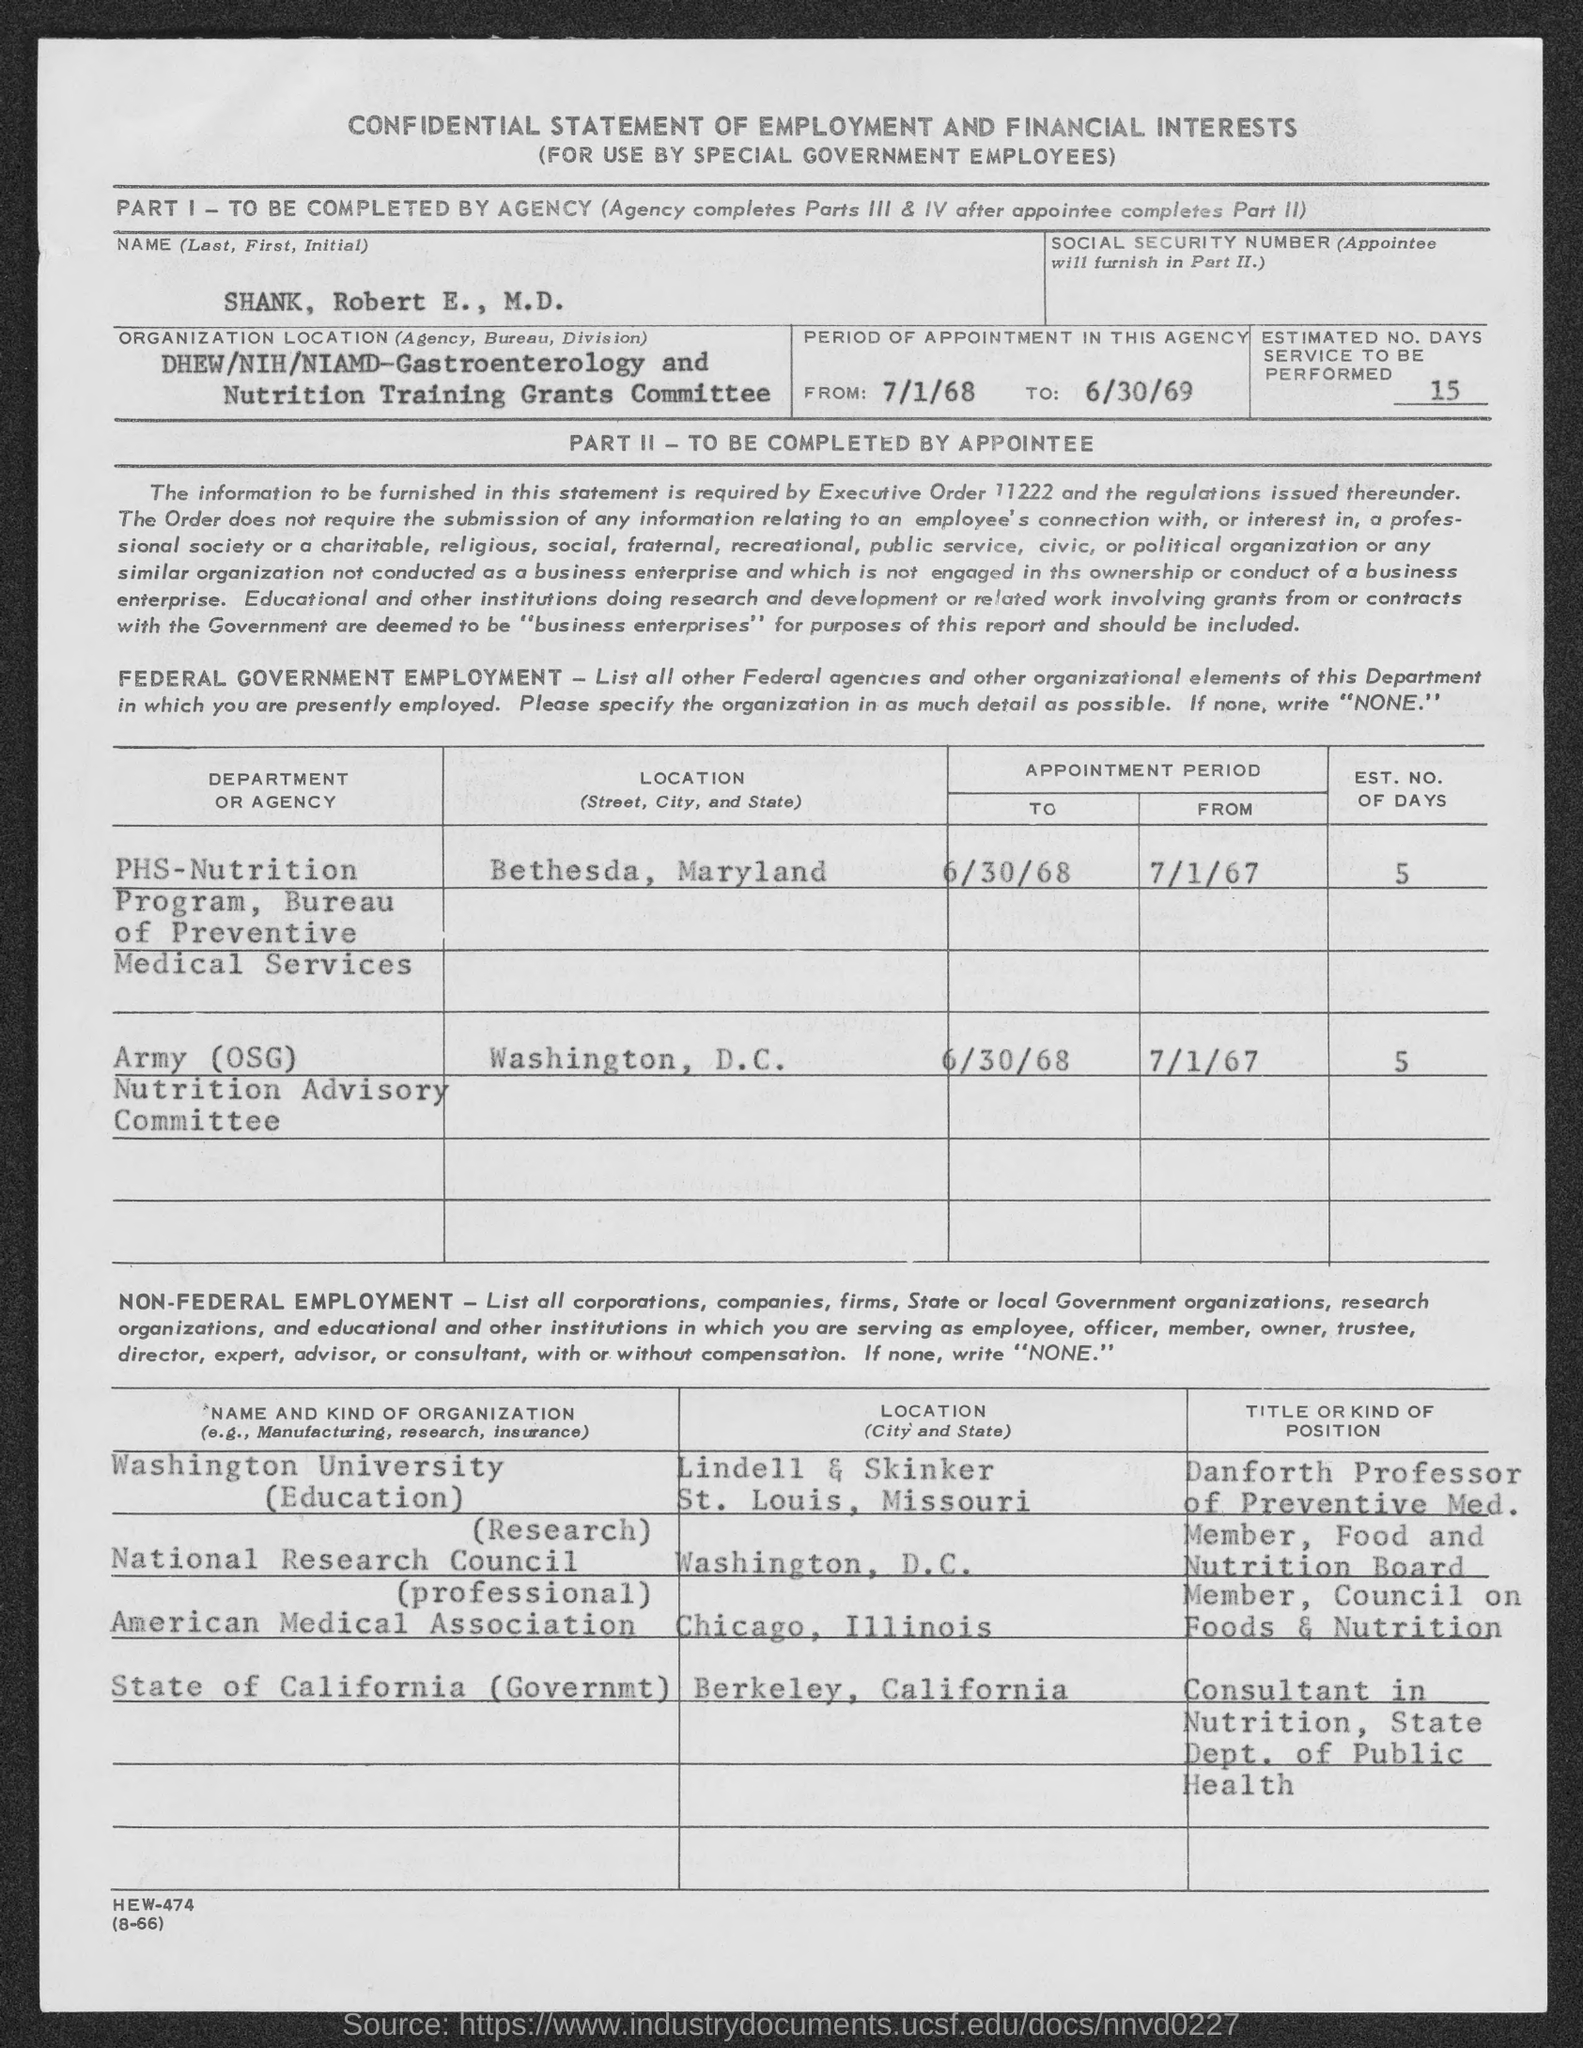What is the heading of the "STATEMENT"?
Provide a short and direct response. Confidential Statement of Employment and Financial Interests. Provide the "NAME(Last, First, Initial)" given in the statement?
Ensure brevity in your answer.  SHANK, Robert  E., M.D. Provide the "ESTIMATED NO. DAYS SERVICE TO BE PERFORMED"?
Offer a very short reply. 15. Provide the LOCATION of "PHS-NUTRITION Program" ?
Provide a succinct answer. Bethesda, Maryland. Provide the LOCATION of "Army(OSG) Nutrition Advisory Committee"?
Keep it short and to the point. Washington,  D.C. Provide the "EST. NO OF DAYS" of "PHS-NUTRITION Program" ?
Provide a short and direct response. 5. Provide the "EST. NO OF DAYS" of "Army(OSG) Nutrition Advisory Committee"?
Your answer should be compact. 5. Provide the LOCATION of "Washington University" ?
Your answer should be very brief. Lindell & Skinker St. Louis, Missouri. Provide the LOCATION of "National Research Council" ?
Your response must be concise. Washington, D.C. 